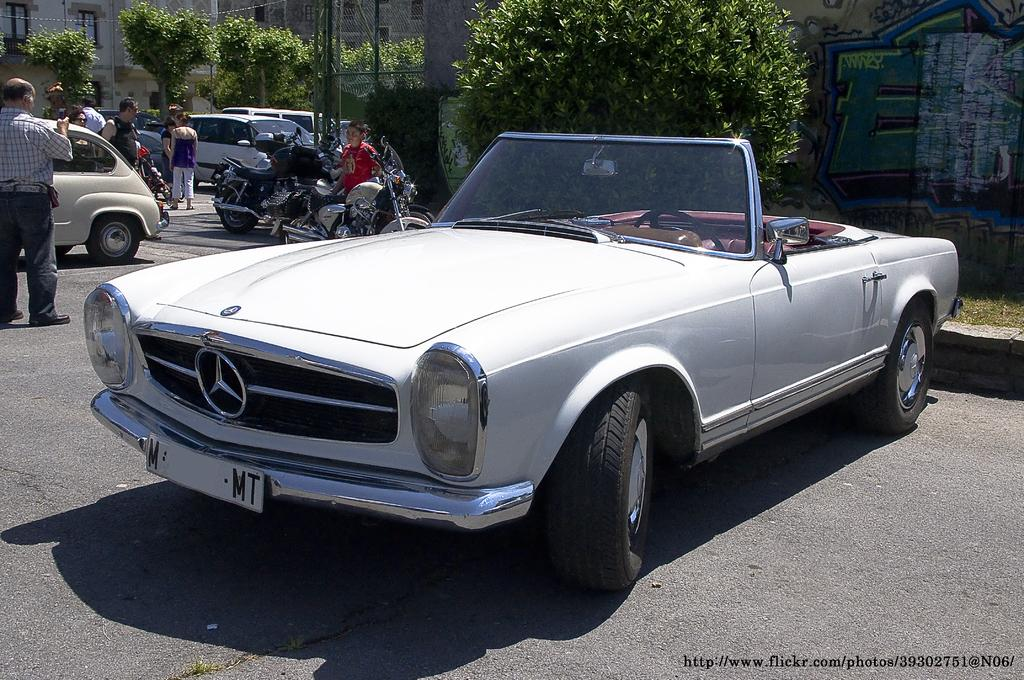What is the main subject of the image? The main subject of the image is fleets of vehicles. What else can be seen on the road in the image? There is a group of people on the road in the image. What can be seen in the background of the image? There are trees, light poles, and buildings in the background of the image. What type of location does the image appear to be taken at? The image appears to be taken on a road. Can you see any ghosts interacting with the vehicles in the image? There are no ghosts present in the image. What type of organization is responsible for the flock of vehicles in the image? There is no mention of a flock of vehicles in the image, and no organization is mentioned or implied. 